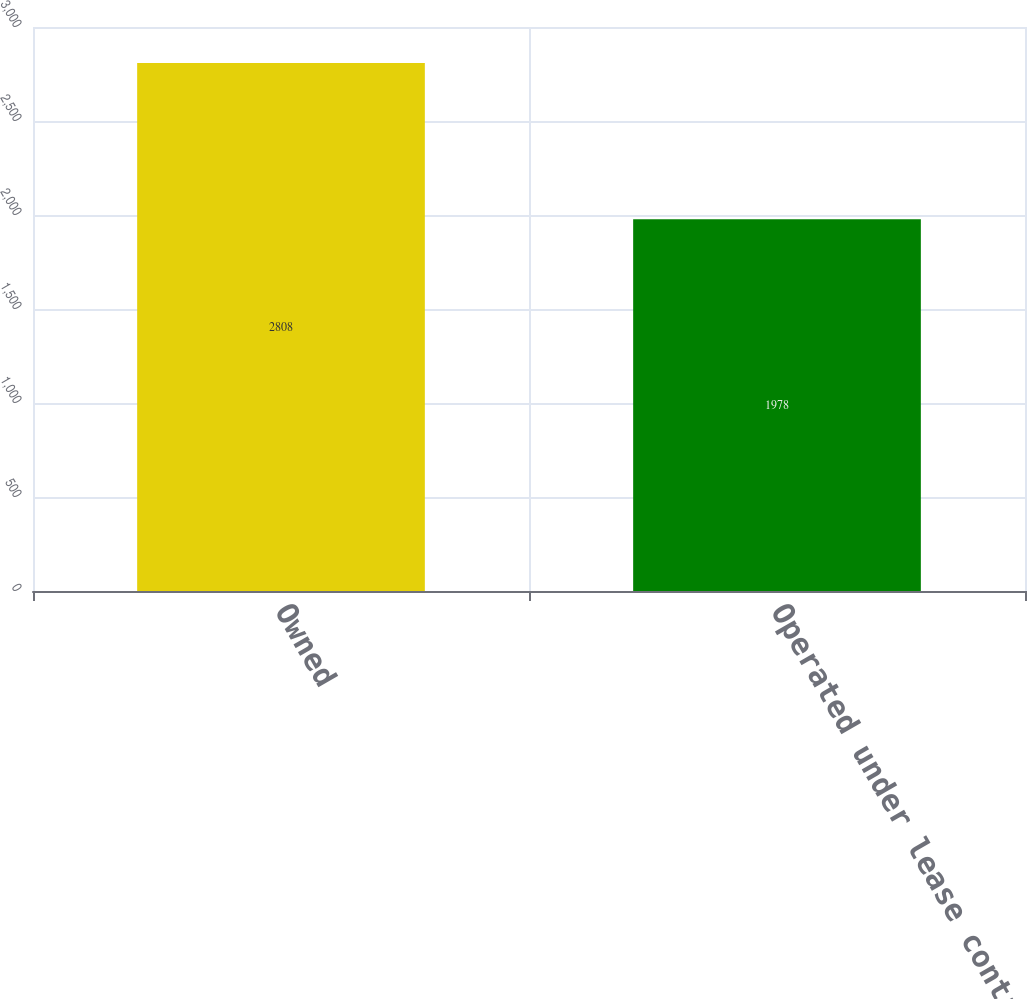<chart> <loc_0><loc_0><loc_500><loc_500><bar_chart><fcel>Owned<fcel>Operated under lease contract<nl><fcel>2808<fcel>1978<nl></chart> 